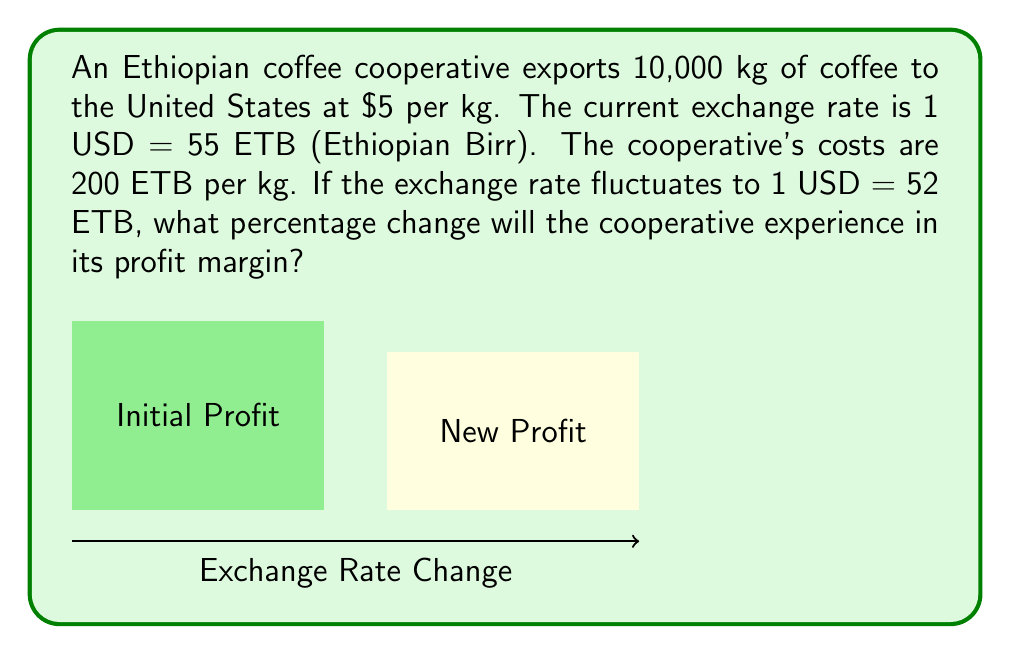Could you help me with this problem? Let's solve this step-by-step:

1) First, calculate the initial profit in ETB:
   Revenue = 10,000 kg × $5/kg × 55 ETB/USD = 2,750,000 ETB
   Costs = 10,000 kg × 200 ETB/kg = 2,000,000 ETB
   Initial Profit = 2,750,000 - 2,000,000 = 750,000 ETB

2) Calculate the initial profit margin:
   Profit Margin = Profit / Revenue
   $$\text{Initial Profit Margin} = \frac{750,000}{2,750,000} = 0.2727 \text{ or } 27.27\%$$

3) Now, calculate the new profit with the changed exchange rate:
   New Revenue = 10,000 kg × $5/kg × 52 ETB/USD = 2,600,000 ETB
   Costs remain the same at 2,000,000 ETB
   New Profit = 2,600,000 - 2,000,000 = 600,000 ETB

4) Calculate the new profit margin:
   $$\text{New Profit Margin} = \frac{600,000}{2,600,000} = 0.2308 \text{ or } 23.08\%$$

5) Calculate the percentage change in profit margin:
   $$\text{Percentage Change} = \frac{\text{New Margin} - \text{Initial Margin}}{\text{Initial Margin}} \times 100\%$$
   $$= \frac{0.2308 - 0.2727}{0.2727} \times 100\% = -15.37\%$$
Answer: -15.37% 